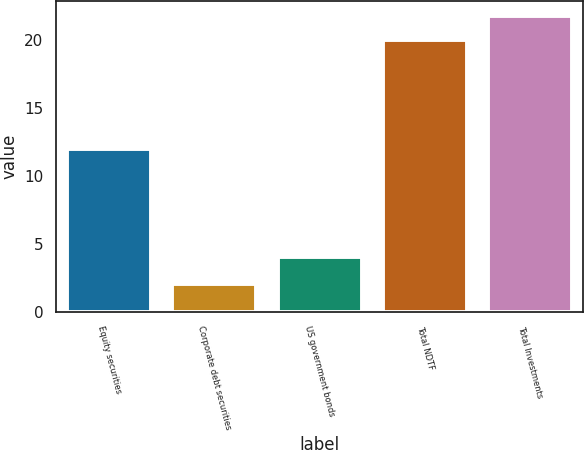<chart> <loc_0><loc_0><loc_500><loc_500><bar_chart><fcel>Equity securities<fcel>Corporate debt securities<fcel>US government bonds<fcel>Total NDTF<fcel>Total Investments<nl><fcel>12<fcel>2<fcel>4<fcel>20<fcel>21.8<nl></chart> 